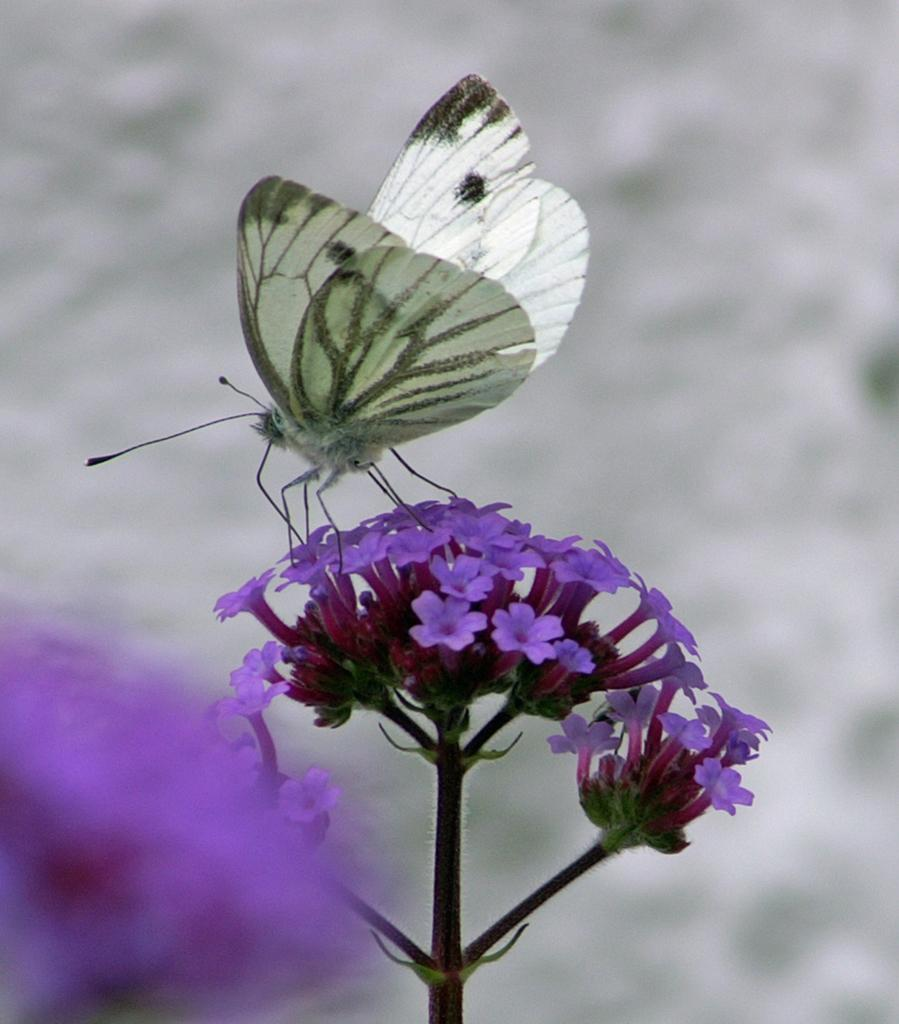What is the main subject of the image? There is a flower in the image. Is there anything interacting with the flower? Yes, there is a butterfly on the flower. What type of note can be seen attached to the sail in the image? There is no sail or note present in the image; it features a flower with a butterfly on it. 